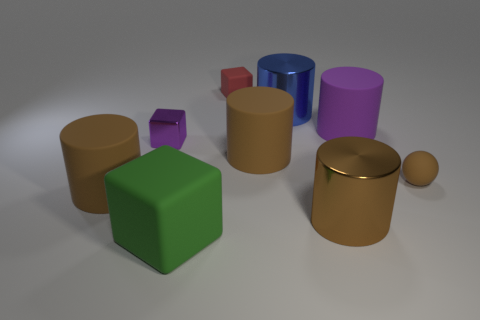Do the green rubber thing and the brown metallic object have the same shape?
Ensure brevity in your answer.  No. The green rubber object is what size?
Your answer should be compact. Large. Are there more brown rubber cylinders that are behind the big green cube than big cubes right of the tiny red block?
Keep it short and to the point. Yes. Are there any big metallic cylinders to the left of the blue metal thing?
Give a very brief answer. No. Is there a sphere that has the same size as the purple metallic block?
Provide a succinct answer. Yes. What color is the tiny thing that is made of the same material as the tiny red cube?
Your answer should be very brief. Brown. What is the material of the purple block?
Provide a short and direct response. Metal. What shape is the big brown metal object?
Your answer should be compact. Cylinder. How many large objects have the same color as the shiny block?
Your answer should be very brief. 1. What material is the tiny purple block that is on the left side of the small rubber ball right of the small matte thing that is behind the rubber ball?
Your answer should be very brief. Metal. 